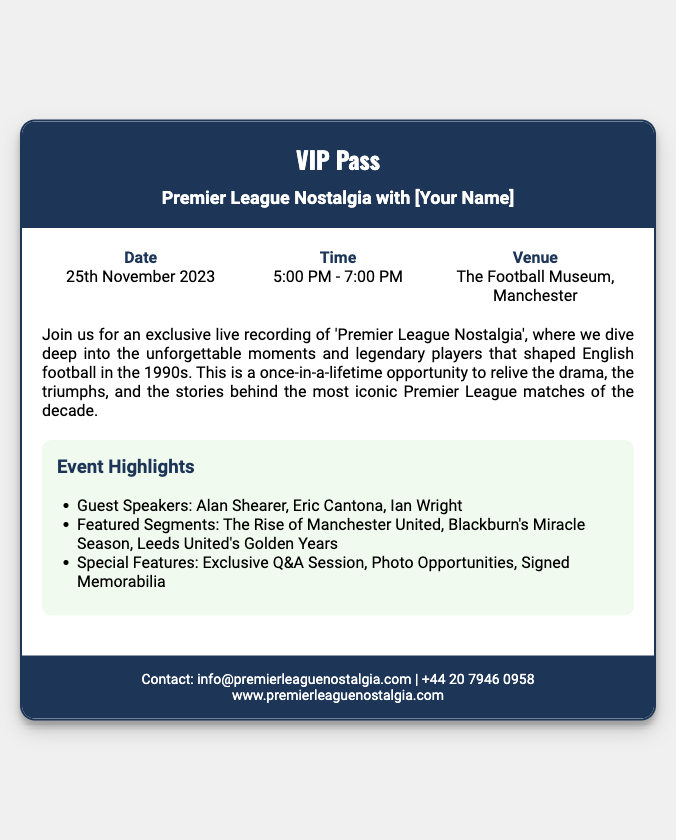What is the date of the event? The date of the event is specified in the ticket, which is 25th November 2023.
Answer: 25th November 2023 What is the time duration of the event? The ticket states that the event will take place from 5:00 PM to 7:00 PM.
Answer: 5:00 PM - 7:00 PM Where is the event being held? The ticket mentions that the venue for the event is The Football Museum, Manchester.
Answer: The Football Museum, Manchester Who are the guest speakers at the event? The highlights in the document list the guest speakers as Alan Shearer, Eric Cantona, and Ian Wright.
Answer: Alan Shearer, Eric Cantona, Ian Wright What is one of the featured segments? The document includes segments such as The Rise of Manchester United, which is one specific example.
Answer: The Rise of Manchester United What type of session will be included at the event? The ticket mentions that there will be an Exclusive Q&A Session as part of the event's highlights.
Answer: Exclusive Q&A Session What is the main theme of the podcast recording? The description on the ticket indicates that the podcast will focus on unforgettable moments and legendary players from the 1990s.
Answer: Unforgettable moments and legendary players from the 1990s 